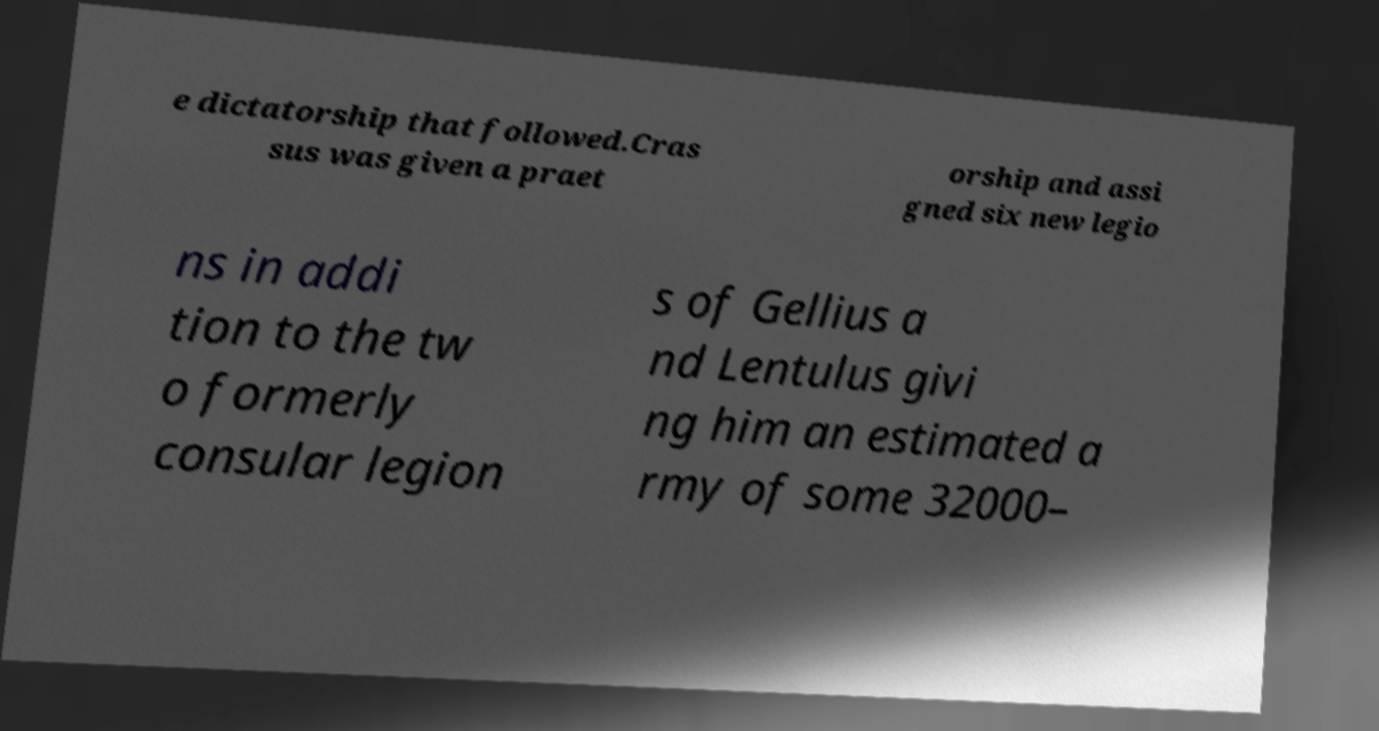What messages or text are displayed in this image? I need them in a readable, typed format. e dictatorship that followed.Cras sus was given a praet orship and assi gned six new legio ns in addi tion to the tw o formerly consular legion s of Gellius a nd Lentulus givi ng him an estimated a rmy of some 32000– 